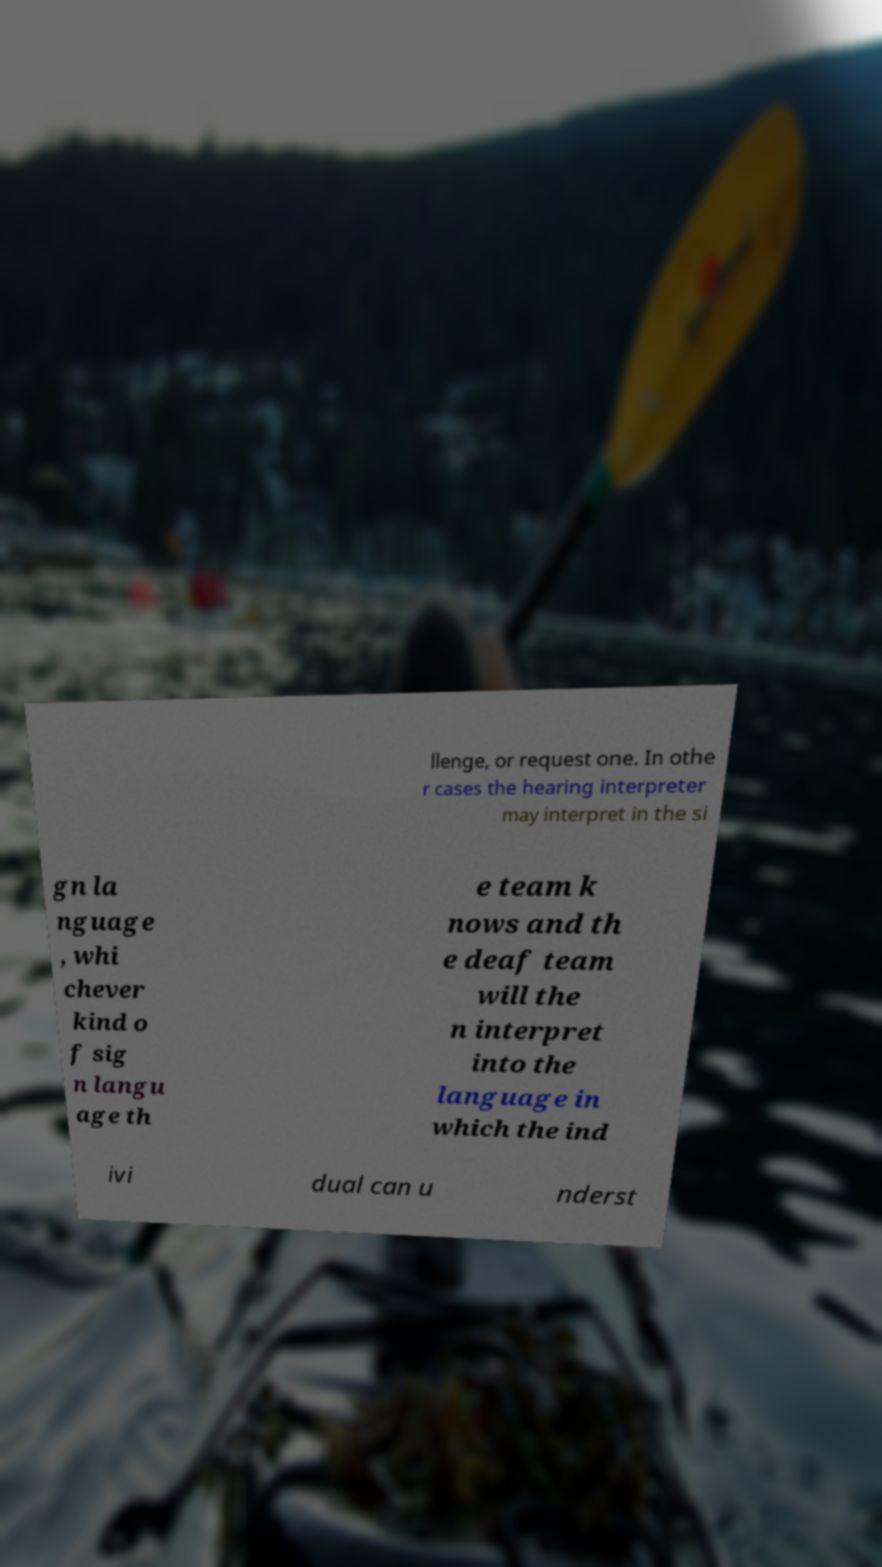Please read and relay the text visible in this image. What does it say? llenge, or request one. In othe r cases the hearing interpreter may interpret in the si gn la nguage , whi chever kind o f sig n langu age th e team k nows and th e deaf team will the n interpret into the language in which the ind ivi dual can u nderst 